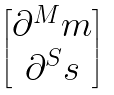<formula> <loc_0><loc_0><loc_500><loc_500>\begin{bmatrix} \partial ^ { M } m \\ \partial ^ { S } s \end{bmatrix}</formula> 